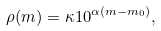<formula> <loc_0><loc_0><loc_500><loc_500>\rho ( m ) = \kappa 1 0 ^ { \alpha ( m - m _ { 0 } ) } ,</formula> 